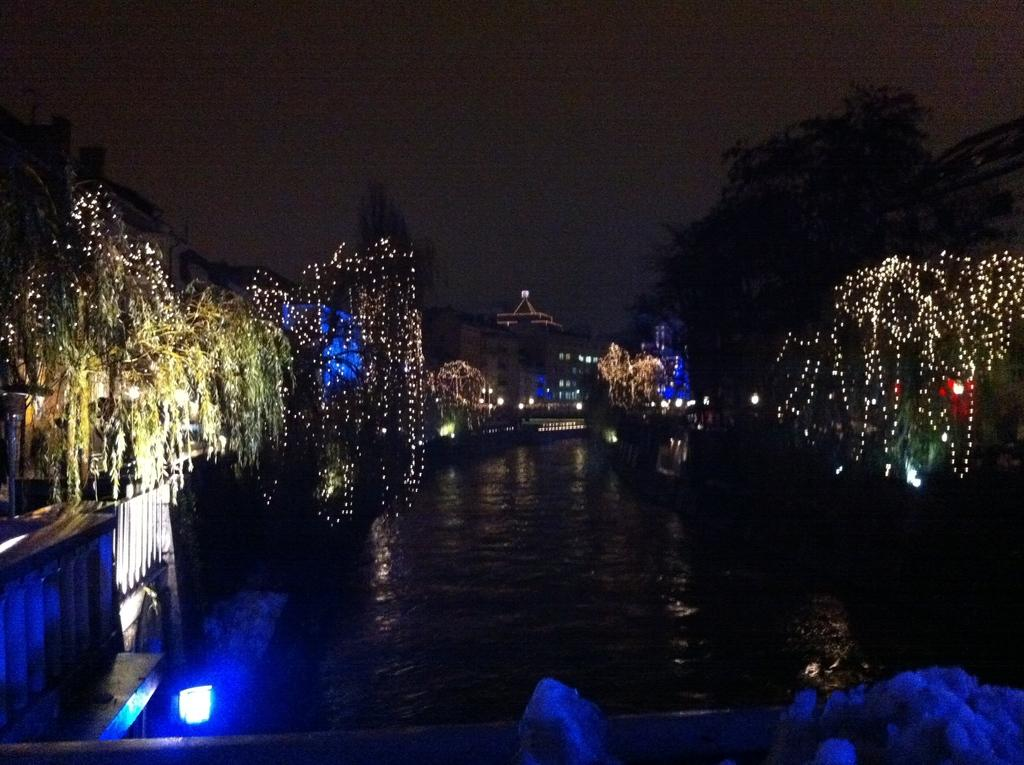What is the main feature in the middle of the image? There is a water body in the middle of the image. What can be seen on both sides of the water body? There are trees and buildings on both sides of the water body. What is the purpose of the lights on the trees? The lights on the trees are likely for decoration or illumination. What type of wood is used to make the bell in the image? There is no bell present in the image, so it is not possible to determine the type of wood used to make it. 